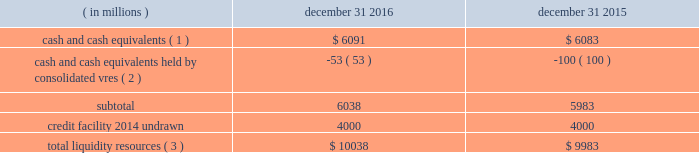Sources of blackrock 2019s operating cash primarily include investment advisory , administration fees and securities lending revenue , performance fees , revenue from blackrock solutions and advisory products and services , other revenue and distribution fees .
Blackrock uses its cash to pay all operating expense , interest and principal on borrowings , income taxes , dividends on blackrock 2019s capital stock , repurchases of the company 2019s stock , capital expenditures and purchases of co-investments and seed investments .
For details of the company 2019s gaap cash flows from operating , investing and financing activities , see the consolidated statements of cash flows contained in part ii , item 8 of this filing .
Cash flows from operating activities , excluding the impact of consolidated sponsored investment funds , primarily include the receipt of investment advisory and administration fees , securities lending revenue and performance fees offset by the payment of operating expenses incurred in the normal course of business , including year-end incentive compensation accrued for in the prior year .
Cash outflows from investing activities , excluding the impact of consolidated sponsored investment funds , for 2016 were $ 58 million and primarily reflected $ 384 million of investment purchases , $ 119 million of purchases of property and equipment and $ 30 million related to an acquisition , partially offset by $ 441 million of net proceeds from sales and maturities of certain investments .
Cash outflows from financing activities , excluding the impact of consolidated sponsored investment funds , for 2016 were $ 2831 million , primarily resulting from $ 1.4 billion of share repurchases , including $ 1.1 billion in open market- transactions and $ 274 million of employee tax withholdings related to employee stock transactions and $ 1.5 billion of cash dividend payments , partially offset by $ 82 million of excess tax benefits from vested stock-based compensation awards .
The company manages its financial condition and funding to maintain appropriate liquidity for the business .
Liquidity resources at december 31 , 2016 and 2015 were as follows : ( in millions ) december 31 , december 31 , cash and cash equivalents ( 1 ) $ 6091 $ 6083 cash and cash equivalents held by consolidated vres ( 2 ) ( 53 ) ( 100 ) .
Total liquidity resources ( 3 ) $ 10038 $ 9983 ( 1 ) the percentage of cash and cash equivalents held by the company 2019s u.s .
Subsidiaries was approximately 50% ( 50 % ) at both december 31 , 2016 and 2015 .
See net capital requirements herein for more information on net capital requirements in certain regulated subsidiaries .
( 2 ) the company cannot readily access such cash to use in its operating activities .
( 3 ) amounts do not reflect year-end incentive compensation accruals of approximately $ 1.3 billion and $ 1.5 billion for 2016 and 2015 , respectively , which were paid in the first quarter of the following year .
Total liquidity resources increased $ 55 million during 2016 , primarily reflecting cash flows from operating activities , partially offset by cash payments of 2015 year-end incentive awards , share repurchases of $ 1.4 billion and cash dividend payments of $ 1.5 billion .
A significant portion of the company 2019s $ 2414 million of total investments , as adjusted , is illiquid in nature and , as such , cannot be readily convertible to cash .
Share repurchases .
The company repurchased 3.3 million common shares in open market-transactions under its share repurchase program for $ 1.1 billion during 2016 .
At december 31 , 2016 , there were 3 million shares still authorized to be repurchased .
In january 2017 , the board of directors approved an increase in the shares that may be repurchased under the company 2019s existing share repurchase program to allow for the repurchase of an additional 6 million shares for a total up to 9 million shares of blackrock common stock .
Net capital requirements .
The company is required to maintain net capital in certain regulated subsidiaries within a number of jurisdictions , which is partially maintained by retaining cash and cash equivalent investments in those subsidiaries or jurisdictions .
As a result , such subsidiaries of the company may be restricted in their ability to transfer cash between different jurisdictions and to their parents .
Additionally , transfers of cash between international jurisdictions , including repatriation to the united states , may have adverse tax consequences that could discourage such transfers .
Blackrock institutional trust company , n.a .
( 201cbtc 201d ) is chartered as a national bank that does not accept client deposits and whose powers are limited to trust and other fiduciary activities .
Btc provides investment management services , including investment advisory and securities lending agency services , to institutional investors and other clients .
Btc is subject to regulatory capital and liquid asset requirements administered by the office of the comptroller of the currency .
At december 31 , 2016 and 2015 , the company was required to maintain approximately $ 1.4 billion and $ 1.1 billion , respectively , in net capital in certain regulated subsidiaries , including btc , entities regulated by the financial conduct authority and prudential regulation authority in the united kingdom , and the company 2019s broker-dealers .
The company was in compliance with all applicable regulatory net capital requirements .
Undistributed earnings of foreign subsidiaries .
As of december 31 , 2016 , the company has not provided for u.s .
Federal and state income taxes on approximately $ 5.3 billion of undistributed earnings of its foreign subsidiaries .
Such earnings are considered indefinitely reinvested outside the united states .
The company 2019s current plans do not demonstrate a need to repatriate these funds .
Short-term borrowings 2016 revolving credit facility .
The company 2019s credit facility has an aggregate commitment amount of $ 4.0 billion and was amended in april 2016 to extend the maturity date to march 2021 ( the 201c2016 credit facility 201d ) .
The 2016 credit facility permits the company to request up to an additional $ 1.0 billion of borrowing capacity , subject to lender credit approval , increasing the overall size of the 2016 credit facility to an aggregate principal amount not to exceed $ 5.0 billion .
Interest on borrowings outstanding accrues at a rate based on the applicable london interbank offered rate plus a spread .
The 2016 credit facility requires the company not to exceed a maximum leverage ratio ( ratio of net debt to .
What is the average price of the repurchased shares during 2016? 
Computations: ((1.1 * 1000) / 3.3)
Answer: 333.33333. 